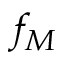Convert formula to latex. <formula><loc_0><loc_0><loc_500><loc_500>f _ { M }</formula> 